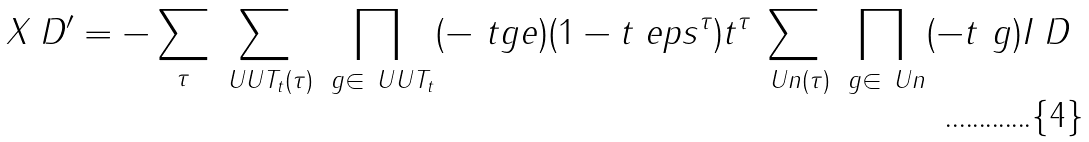Convert formula to latex. <formula><loc_0><loc_0><loc_500><loc_500>X _ { \ } D ^ { \prime } = - \sum _ { \tau } \sum _ { \ U U T _ { t } ( \tau ) } \prod _ { \ g \in \ U U T _ { t } } ( - \ t g e ) ( 1 - t _ { \ } e p s ^ { \tau } ) t ^ { \tau } \sum _ { \ U n ( \tau ) } \prod _ { \ g \in \ U n } ( - t ^ { \ } g ) I _ { \ } D</formula> 